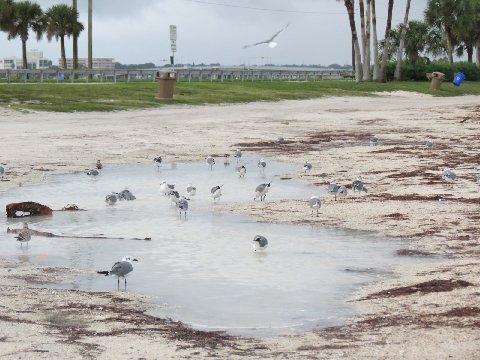How many birds are in this picture?
Concise answer only. 25. What sort of disaster is happening?
Concise answer only. Drought. Why is there water on the ground?
Write a very short answer. Rain. How many birds are in the picture?
Be succinct. 20. Is a bird about to land?
Answer briefly. Yes. What animals are visible?
Answer briefly. Birds. What kind of trees are on the left?
Concise answer only. Palm. Is the ground damp?
Write a very short answer. Yes. What type of birds are in the sand?
Answer briefly. Seagulls. Do you see any garbage cans?
Be succinct. Yes. Are these animals considered mammals?
Quick response, please. No. 